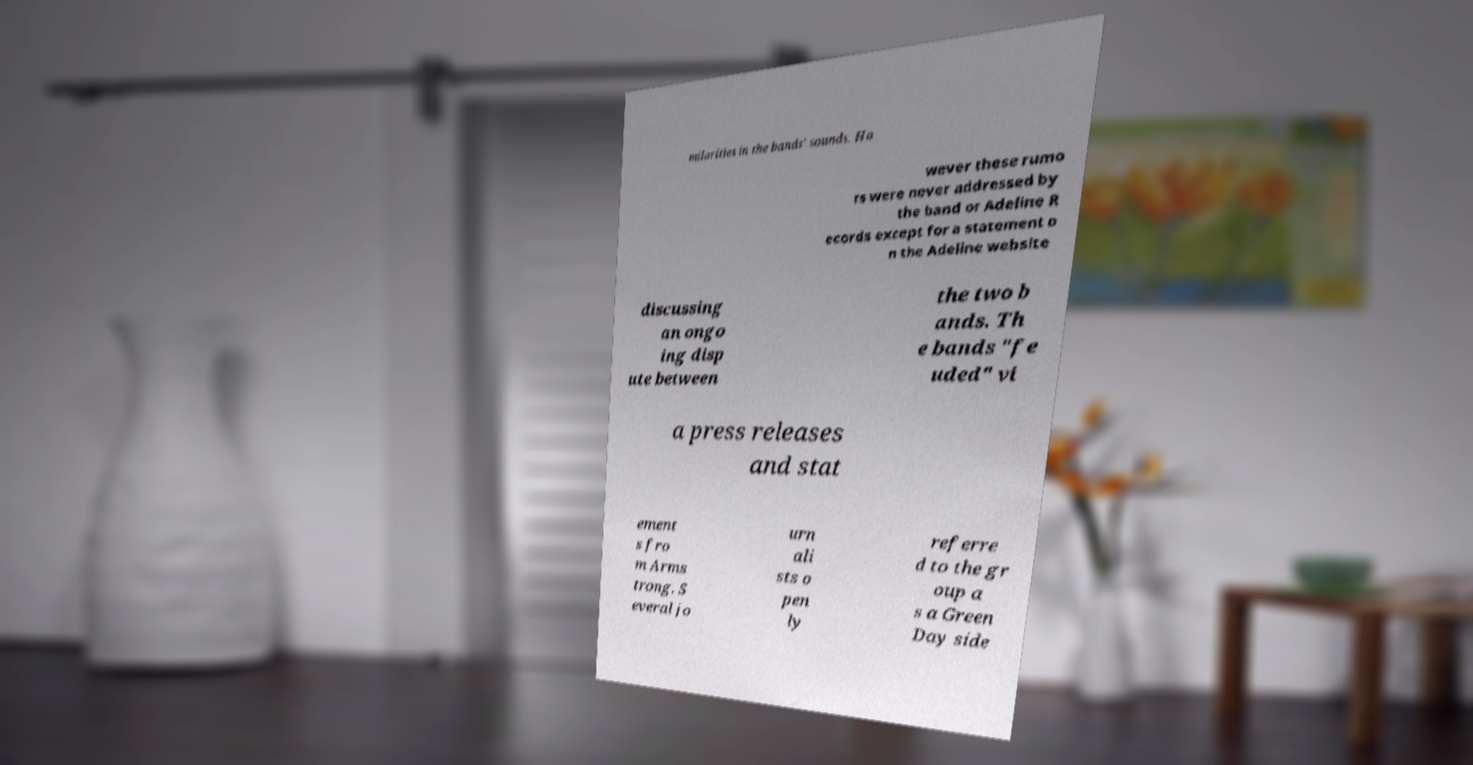Could you assist in decoding the text presented in this image and type it out clearly? milarities in the bands' sounds. Ho wever these rumo rs were never addressed by the band or Adeline R ecords except for a statement o n the Adeline website discussing an ongo ing disp ute between the two b ands. Th e bands "fe uded" vi a press releases and stat ement s fro m Arms trong. S everal jo urn ali sts o pen ly referre d to the gr oup a s a Green Day side 